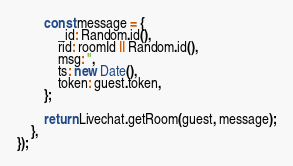<code> <loc_0><loc_0><loc_500><loc_500><_JavaScript_>
		const message = {
			_id: Random.id(),
			rid: roomId || Random.id(),
			msg: '',
			ts: new Date(),
			token: guest.token,
		};

		return Livechat.getRoom(guest, message);
	},
});
</code> 